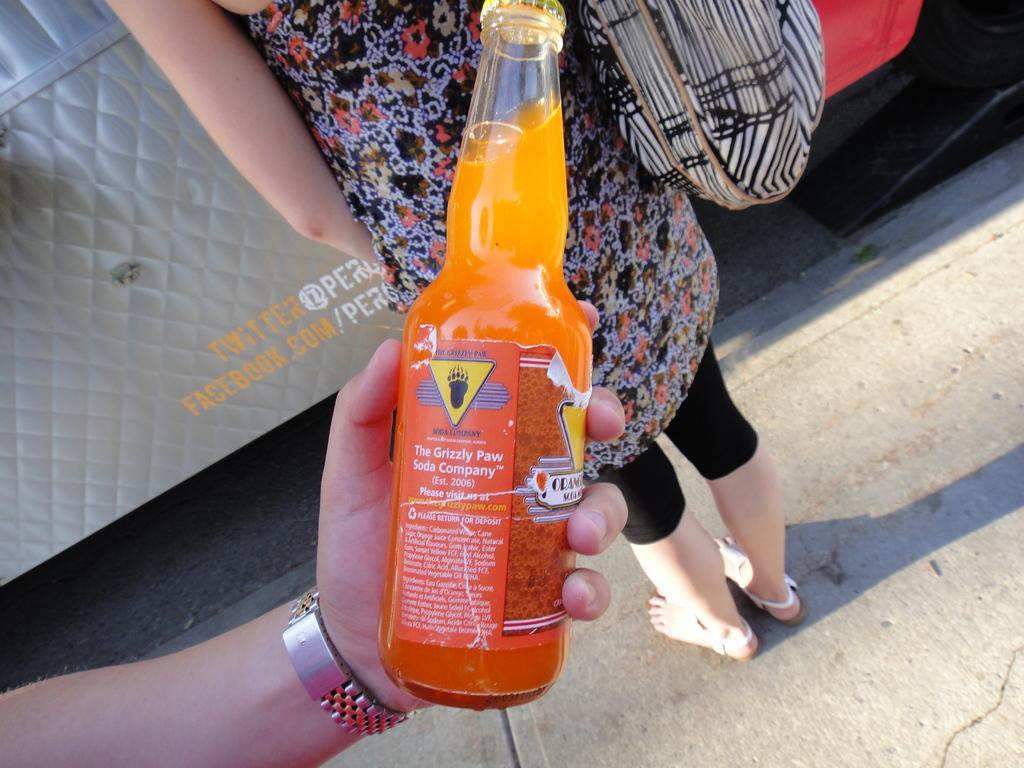Can you describe this image briefly? In this image i can see a person's hand holding a bottle with orange liquid in it. I can see a watch to that hand. In the background i can see a woman wearing a black dress standing and wearing a bag. 